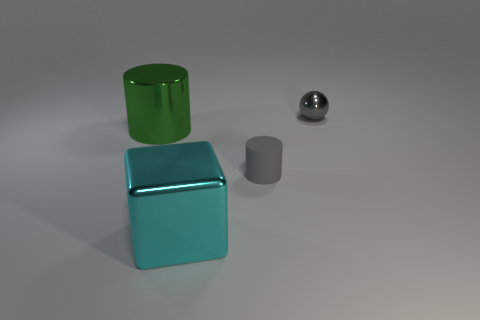Add 4 gray metallic balls. How many objects exist? 8 Subtract all cubes. How many objects are left? 3 Subtract 0 red spheres. How many objects are left? 4 Subtract all large green metal things. Subtract all cubes. How many objects are left? 2 Add 1 large cyan metallic objects. How many large cyan metallic objects are left? 2 Add 2 small yellow rubber cubes. How many small yellow rubber cubes exist? 2 